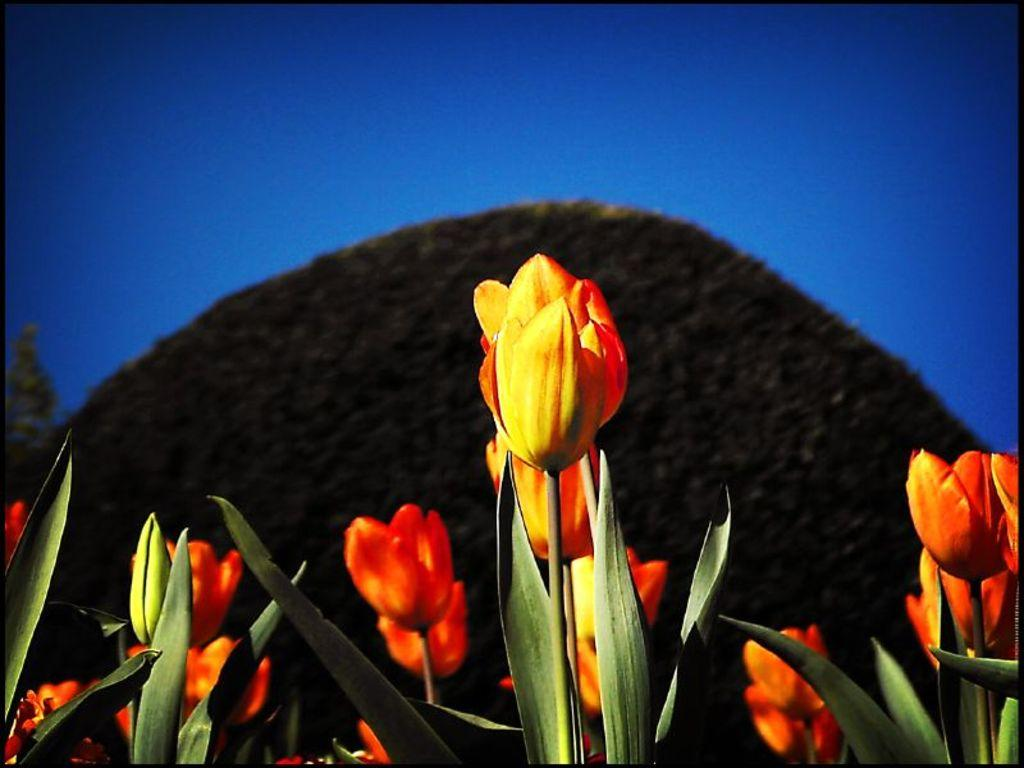What type of objects can be seen in the image? There are flowers in the image. Can you describe the colors of the flowers? The flowers are red and yellow in color. What can be seen in the background of the image? There is a blue color view in the background of the image. What type of sound can be heard coming from the flowers in the image? There is no sound coming from the flowers in the image, as they are not capable of producing sound. 